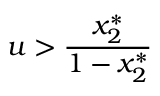<formula> <loc_0><loc_0><loc_500><loc_500>u > \frac { x _ { 2 } ^ { * } } { 1 - x _ { 2 } ^ { * } }</formula> 